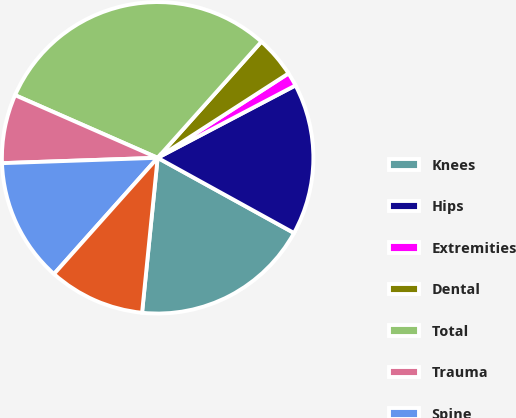Convert chart. <chart><loc_0><loc_0><loc_500><loc_500><pie_chart><fcel>Knees<fcel>Hips<fcel>Extremities<fcel>Dental<fcel>Total<fcel>Trauma<fcel>Spine<fcel>OSP and other<nl><fcel>18.58%<fcel>15.72%<fcel>1.42%<fcel>4.28%<fcel>30.02%<fcel>7.14%<fcel>12.86%<fcel>10.0%<nl></chart> 